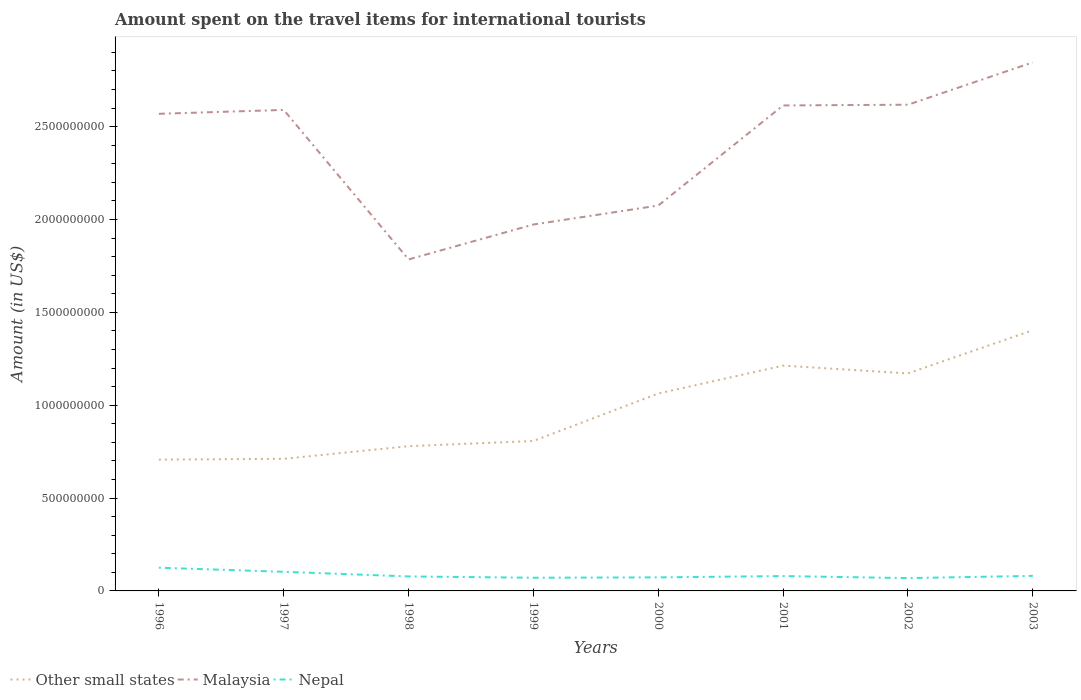Is the number of lines equal to the number of legend labels?
Give a very brief answer. Yes. Across all years, what is the maximum amount spent on the travel items for international tourists in Nepal?
Make the answer very short. 6.90e+07. What is the total amount spent on the travel items for international tourists in Other small states in the graph?
Make the answer very short. -5.02e+08. What is the difference between the highest and the second highest amount spent on the travel items for international tourists in Malaysia?
Keep it short and to the point. 1.06e+09. Is the amount spent on the travel items for international tourists in Nepal strictly greater than the amount spent on the travel items for international tourists in Malaysia over the years?
Your answer should be compact. Yes. How many years are there in the graph?
Your answer should be very brief. 8. What is the difference between two consecutive major ticks on the Y-axis?
Offer a very short reply. 5.00e+08. Does the graph contain any zero values?
Provide a succinct answer. No. How are the legend labels stacked?
Make the answer very short. Horizontal. What is the title of the graph?
Make the answer very short. Amount spent on the travel items for international tourists. What is the label or title of the Y-axis?
Provide a short and direct response. Amount (in US$). What is the Amount (in US$) of Other small states in 1996?
Your answer should be compact. 7.07e+08. What is the Amount (in US$) in Malaysia in 1996?
Offer a very short reply. 2.57e+09. What is the Amount (in US$) of Nepal in 1996?
Your answer should be very brief. 1.25e+08. What is the Amount (in US$) in Other small states in 1997?
Keep it short and to the point. 7.11e+08. What is the Amount (in US$) in Malaysia in 1997?
Your answer should be very brief. 2.59e+09. What is the Amount (in US$) in Nepal in 1997?
Offer a terse response. 1.03e+08. What is the Amount (in US$) of Other small states in 1998?
Provide a short and direct response. 7.79e+08. What is the Amount (in US$) in Malaysia in 1998?
Your answer should be very brief. 1.78e+09. What is the Amount (in US$) in Nepal in 1998?
Ensure brevity in your answer.  7.80e+07. What is the Amount (in US$) of Other small states in 1999?
Provide a short and direct response. 8.07e+08. What is the Amount (in US$) in Malaysia in 1999?
Your answer should be compact. 1.97e+09. What is the Amount (in US$) of Nepal in 1999?
Your answer should be very brief. 7.10e+07. What is the Amount (in US$) in Other small states in 2000?
Keep it short and to the point. 1.06e+09. What is the Amount (in US$) in Malaysia in 2000?
Provide a short and direct response. 2.08e+09. What is the Amount (in US$) in Nepal in 2000?
Ensure brevity in your answer.  7.30e+07. What is the Amount (in US$) in Other small states in 2001?
Offer a very short reply. 1.21e+09. What is the Amount (in US$) in Malaysia in 2001?
Your answer should be very brief. 2.61e+09. What is the Amount (in US$) in Nepal in 2001?
Your answer should be very brief. 8.00e+07. What is the Amount (in US$) in Other small states in 2002?
Give a very brief answer. 1.17e+09. What is the Amount (in US$) of Malaysia in 2002?
Ensure brevity in your answer.  2.62e+09. What is the Amount (in US$) of Nepal in 2002?
Your answer should be compact. 6.90e+07. What is the Amount (in US$) of Other small states in 2003?
Provide a short and direct response. 1.40e+09. What is the Amount (in US$) of Malaysia in 2003?
Keep it short and to the point. 2.85e+09. What is the Amount (in US$) of Nepal in 2003?
Make the answer very short. 8.10e+07. Across all years, what is the maximum Amount (in US$) of Other small states?
Your answer should be very brief. 1.40e+09. Across all years, what is the maximum Amount (in US$) of Malaysia?
Keep it short and to the point. 2.85e+09. Across all years, what is the maximum Amount (in US$) of Nepal?
Offer a terse response. 1.25e+08. Across all years, what is the minimum Amount (in US$) in Other small states?
Your answer should be compact. 7.07e+08. Across all years, what is the minimum Amount (in US$) in Malaysia?
Make the answer very short. 1.78e+09. Across all years, what is the minimum Amount (in US$) in Nepal?
Your answer should be compact. 6.90e+07. What is the total Amount (in US$) in Other small states in the graph?
Keep it short and to the point. 7.86e+09. What is the total Amount (in US$) in Malaysia in the graph?
Your response must be concise. 1.91e+1. What is the total Amount (in US$) of Nepal in the graph?
Make the answer very short. 6.80e+08. What is the difference between the Amount (in US$) in Other small states in 1996 and that in 1997?
Your answer should be compact. -4.32e+06. What is the difference between the Amount (in US$) in Malaysia in 1996 and that in 1997?
Offer a terse response. -2.10e+07. What is the difference between the Amount (in US$) of Nepal in 1996 and that in 1997?
Provide a succinct answer. 2.20e+07. What is the difference between the Amount (in US$) of Other small states in 1996 and that in 1998?
Keep it short and to the point. -7.23e+07. What is the difference between the Amount (in US$) of Malaysia in 1996 and that in 1998?
Provide a short and direct response. 7.84e+08. What is the difference between the Amount (in US$) in Nepal in 1996 and that in 1998?
Your answer should be compact. 4.70e+07. What is the difference between the Amount (in US$) of Other small states in 1996 and that in 1999?
Offer a very short reply. -1.00e+08. What is the difference between the Amount (in US$) in Malaysia in 1996 and that in 1999?
Offer a terse response. 5.96e+08. What is the difference between the Amount (in US$) of Nepal in 1996 and that in 1999?
Your answer should be very brief. 5.40e+07. What is the difference between the Amount (in US$) of Other small states in 1996 and that in 2000?
Ensure brevity in your answer.  -3.56e+08. What is the difference between the Amount (in US$) in Malaysia in 1996 and that in 2000?
Keep it short and to the point. 4.94e+08. What is the difference between the Amount (in US$) of Nepal in 1996 and that in 2000?
Your response must be concise. 5.20e+07. What is the difference between the Amount (in US$) in Other small states in 1996 and that in 2001?
Your answer should be compact. -5.06e+08. What is the difference between the Amount (in US$) of Malaysia in 1996 and that in 2001?
Your response must be concise. -4.50e+07. What is the difference between the Amount (in US$) in Nepal in 1996 and that in 2001?
Offer a terse response. 4.50e+07. What is the difference between the Amount (in US$) of Other small states in 1996 and that in 2002?
Your answer should be compact. -4.64e+08. What is the difference between the Amount (in US$) in Malaysia in 1996 and that in 2002?
Offer a very short reply. -4.90e+07. What is the difference between the Amount (in US$) of Nepal in 1996 and that in 2002?
Offer a terse response. 5.60e+07. What is the difference between the Amount (in US$) in Other small states in 1996 and that in 2003?
Provide a short and direct response. -6.97e+08. What is the difference between the Amount (in US$) of Malaysia in 1996 and that in 2003?
Your answer should be compact. -2.77e+08. What is the difference between the Amount (in US$) in Nepal in 1996 and that in 2003?
Your answer should be compact. 4.40e+07. What is the difference between the Amount (in US$) in Other small states in 1997 and that in 1998?
Give a very brief answer. -6.80e+07. What is the difference between the Amount (in US$) of Malaysia in 1997 and that in 1998?
Offer a very short reply. 8.05e+08. What is the difference between the Amount (in US$) in Nepal in 1997 and that in 1998?
Offer a terse response. 2.50e+07. What is the difference between the Amount (in US$) of Other small states in 1997 and that in 1999?
Offer a terse response. -9.60e+07. What is the difference between the Amount (in US$) of Malaysia in 1997 and that in 1999?
Ensure brevity in your answer.  6.17e+08. What is the difference between the Amount (in US$) of Nepal in 1997 and that in 1999?
Your response must be concise. 3.20e+07. What is the difference between the Amount (in US$) of Other small states in 1997 and that in 2000?
Your response must be concise. -3.52e+08. What is the difference between the Amount (in US$) in Malaysia in 1997 and that in 2000?
Your answer should be very brief. 5.15e+08. What is the difference between the Amount (in US$) in Nepal in 1997 and that in 2000?
Ensure brevity in your answer.  3.00e+07. What is the difference between the Amount (in US$) of Other small states in 1997 and that in 2001?
Your response must be concise. -5.02e+08. What is the difference between the Amount (in US$) in Malaysia in 1997 and that in 2001?
Your answer should be very brief. -2.40e+07. What is the difference between the Amount (in US$) of Nepal in 1997 and that in 2001?
Your answer should be very brief. 2.30e+07. What is the difference between the Amount (in US$) in Other small states in 1997 and that in 2002?
Make the answer very short. -4.60e+08. What is the difference between the Amount (in US$) in Malaysia in 1997 and that in 2002?
Your answer should be compact. -2.80e+07. What is the difference between the Amount (in US$) in Nepal in 1997 and that in 2002?
Give a very brief answer. 3.40e+07. What is the difference between the Amount (in US$) in Other small states in 1997 and that in 2003?
Your answer should be compact. -6.92e+08. What is the difference between the Amount (in US$) of Malaysia in 1997 and that in 2003?
Ensure brevity in your answer.  -2.56e+08. What is the difference between the Amount (in US$) in Nepal in 1997 and that in 2003?
Give a very brief answer. 2.20e+07. What is the difference between the Amount (in US$) of Other small states in 1998 and that in 1999?
Make the answer very short. -2.80e+07. What is the difference between the Amount (in US$) of Malaysia in 1998 and that in 1999?
Offer a very short reply. -1.88e+08. What is the difference between the Amount (in US$) in Other small states in 1998 and that in 2000?
Make the answer very short. -2.84e+08. What is the difference between the Amount (in US$) in Malaysia in 1998 and that in 2000?
Your response must be concise. -2.90e+08. What is the difference between the Amount (in US$) of Nepal in 1998 and that in 2000?
Offer a terse response. 5.00e+06. What is the difference between the Amount (in US$) in Other small states in 1998 and that in 2001?
Provide a succinct answer. -4.34e+08. What is the difference between the Amount (in US$) of Malaysia in 1998 and that in 2001?
Make the answer very short. -8.29e+08. What is the difference between the Amount (in US$) of Nepal in 1998 and that in 2001?
Make the answer very short. -2.00e+06. What is the difference between the Amount (in US$) in Other small states in 1998 and that in 2002?
Offer a terse response. -3.92e+08. What is the difference between the Amount (in US$) of Malaysia in 1998 and that in 2002?
Your response must be concise. -8.33e+08. What is the difference between the Amount (in US$) of Nepal in 1998 and that in 2002?
Your answer should be very brief. 9.00e+06. What is the difference between the Amount (in US$) in Other small states in 1998 and that in 2003?
Your answer should be very brief. -6.24e+08. What is the difference between the Amount (in US$) in Malaysia in 1998 and that in 2003?
Ensure brevity in your answer.  -1.06e+09. What is the difference between the Amount (in US$) of Nepal in 1998 and that in 2003?
Provide a succinct answer. -3.00e+06. What is the difference between the Amount (in US$) of Other small states in 1999 and that in 2000?
Your answer should be compact. -2.56e+08. What is the difference between the Amount (in US$) in Malaysia in 1999 and that in 2000?
Your response must be concise. -1.02e+08. What is the difference between the Amount (in US$) in Other small states in 1999 and that in 2001?
Offer a very short reply. -4.06e+08. What is the difference between the Amount (in US$) of Malaysia in 1999 and that in 2001?
Offer a very short reply. -6.41e+08. What is the difference between the Amount (in US$) of Nepal in 1999 and that in 2001?
Your answer should be compact. -9.00e+06. What is the difference between the Amount (in US$) of Other small states in 1999 and that in 2002?
Offer a very short reply. -3.64e+08. What is the difference between the Amount (in US$) of Malaysia in 1999 and that in 2002?
Your answer should be compact. -6.45e+08. What is the difference between the Amount (in US$) in Nepal in 1999 and that in 2002?
Make the answer very short. 2.00e+06. What is the difference between the Amount (in US$) of Other small states in 1999 and that in 2003?
Your answer should be very brief. -5.96e+08. What is the difference between the Amount (in US$) in Malaysia in 1999 and that in 2003?
Keep it short and to the point. -8.73e+08. What is the difference between the Amount (in US$) of Nepal in 1999 and that in 2003?
Ensure brevity in your answer.  -1.00e+07. What is the difference between the Amount (in US$) of Other small states in 2000 and that in 2001?
Ensure brevity in your answer.  -1.50e+08. What is the difference between the Amount (in US$) in Malaysia in 2000 and that in 2001?
Offer a terse response. -5.39e+08. What is the difference between the Amount (in US$) in Nepal in 2000 and that in 2001?
Provide a succinct answer. -7.00e+06. What is the difference between the Amount (in US$) in Other small states in 2000 and that in 2002?
Provide a short and direct response. -1.08e+08. What is the difference between the Amount (in US$) in Malaysia in 2000 and that in 2002?
Offer a very short reply. -5.43e+08. What is the difference between the Amount (in US$) of Nepal in 2000 and that in 2002?
Give a very brief answer. 4.00e+06. What is the difference between the Amount (in US$) of Other small states in 2000 and that in 2003?
Make the answer very short. -3.41e+08. What is the difference between the Amount (in US$) in Malaysia in 2000 and that in 2003?
Offer a terse response. -7.71e+08. What is the difference between the Amount (in US$) of Nepal in 2000 and that in 2003?
Offer a terse response. -8.00e+06. What is the difference between the Amount (in US$) of Other small states in 2001 and that in 2002?
Provide a succinct answer. 4.19e+07. What is the difference between the Amount (in US$) in Nepal in 2001 and that in 2002?
Offer a terse response. 1.10e+07. What is the difference between the Amount (in US$) of Other small states in 2001 and that in 2003?
Your answer should be compact. -1.91e+08. What is the difference between the Amount (in US$) in Malaysia in 2001 and that in 2003?
Provide a short and direct response. -2.32e+08. What is the difference between the Amount (in US$) in Other small states in 2002 and that in 2003?
Make the answer very short. -2.32e+08. What is the difference between the Amount (in US$) in Malaysia in 2002 and that in 2003?
Give a very brief answer. -2.28e+08. What is the difference between the Amount (in US$) in Nepal in 2002 and that in 2003?
Keep it short and to the point. -1.20e+07. What is the difference between the Amount (in US$) in Other small states in 1996 and the Amount (in US$) in Malaysia in 1997?
Offer a terse response. -1.88e+09. What is the difference between the Amount (in US$) of Other small states in 1996 and the Amount (in US$) of Nepal in 1997?
Offer a terse response. 6.04e+08. What is the difference between the Amount (in US$) in Malaysia in 1996 and the Amount (in US$) in Nepal in 1997?
Give a very brief answer. 2.47e+09. What is the difference between the Amount (in US$) in Other small states in 1996 and the Amount (in US$) in Malaysia in 1998?
Provide a succinct answer. -1.08e+09. What is the difference between the Amount (in US$) in Other small states in 1996 and the Amount (in US$) in Nepal in 1998?
Make the answer very short. 6.29e+08. What is the difference between the Amount (in US$) of Malaysia in 1996 and the Amount (in US$) of Nepal in 1998?
Your response must be concise. 2.49e+09. What is the difference between the Amount (in US$) in Other small states in 1996 and the Amount (in US$) in Malaysia in 1999?
Make the answer very short. -1.27e+09. What is the difference between the Amount (in US$) of Other small states in 1996 and the Amount (in US$) of Nepal in 1999?
Give a very brief answer. 6.36e+08. What is the difference between the Amount (in US$) in Malaysia in 1996 and the Amount (in US$) in Nepal in 1999?
Offer a very short reply. 2.50e+09. What is the difference between the Amount (in US$) of Other small states in 1996 and the Amount (in US$) of Malaysia in 2000?
Your answer should be compact. -1.37e+09. What is the difference between the Amount (in US$) in Other small states in 1996 and the Amount (in US$) in Nepal in 2000?
Make the answer very short. 6.34e+08. What is the difference between the Amount (in US$) in Malaysia in 1996 and the Amount (in US$) in Nepal in 2000?
Provide a short and direct response. 2.50e+09. What is the difference between the Amount (in US$) of Other small states in 1996 and the Amount (in US$) of Malaysia in 2001?
Your response must be concise. -1.91e+09. What is the difference between the Amount (in US$) of Other small states in 1996 and the Amount (in US$) of Nepal in 2001?
Keep it short and to the point. 6.27e+08. What is the difference between the Amount (in US$) in Malaysia in 1996 and the Amount (in US$) in Nepal in 2001?
Your answer should be very brief. 2.49e+09. What is the difference between the Amount (in US$) of Other small states in 1996 and the Amount (in US$) of Malaysia in 2002?
Keep it short and to the point. -1.91e+09. What is the difference between the Amount (in US$) of Other small states in 1996 and the Amount (in US$) of Nepal in 2002?
Give a very brief answer. 6.38e+08. What is the difference between the Amount (in US$) in Malaysia in 1996 and the Amount (in US$) in Nepal in 2002?
Give a very brief answer. 2.50e+09. What is the difference between the Amount (in US$) of Other small states in 1996 and the Amount (in US$) of Malaysia in 2003?
Your answer should be compact. -2.14e+09. What is the difference between the Amount (in US$) in Other small states in 1996 and the Amount (in US$) in Nepal in 2003?
Provide a short and direct response. 6.26e+08. What is the difference between the Amount (in US$) in Malaysia in 1996 and the Amount (in US$) in Nepal in 2003?
Offer a terse response. 2.49e+09. What is the difference between the Amount (in US$) in Other small states in 1997 and the Amount (in US$) in Malaysia in 1998?
Provide a succinct answer. -1.07e+09. What is the difference between the Amount (in US$) in Other small states in 1997 and the Amount (in US$) in Nepal in 1998?
Your response must be concise. 6.33e+08. What is the difference between the Amount (in US$) of Malaysia in 1997 and the Amount (in US$) of Nepal in 1998?
Your answer should be very brief. 2.51e+09. What is the difference between the Amount (in US$) of Other small states in 1997 and the Amount (in US$) of Malaysia in 1999?
Your answer should be compact. -1.26e+09. What is the difference between the Amount (in US$) in Other small states in 1997 and the Amount (in US$) in Nepal in 1999?
Give a very brief answer. 6.40e+08. What is the difference between the Amount (in US$) in Malaysia in 1997 and the Amount (in US$) in Nepal in 1999?
Your answer should be compact. 2.52e+09. What is the difference between the Amount (in US$) in Other small states in 1997 and the Amount (in US$) in Malaysia in 2000?
Provide a succinct answer. -1.36e+09. What is the difference between the Amount (in US$) in Other small states in 1997 and the Amount (in US$) in Nepal in 2000?
Your answer should be very brief. 6.38e+08. What is the difference between the Amount (in US$) of Malaysia in 1997 and the Amount (in US$) of Nepal in 2000?
Give a very brief answer. 2.52e+09. What is the difference between the Amount (in US$) of Other small states in 1997 and the Amount (in US$) of Malaysia in 2001?
Keep it short and to the point. -1.90e+09. What is the difference between the Amount (in US$) in Other small states in 1997 and the Amount (in US$) in Nepal in 2001?
Offer a terse response. 6.31e+08. What is the difference between the Amount (in US$) in Malaysia in 1997 and the Amount (in US$) in Nepal in 2001?
Your answer should be compact. 2.51e+09. What is the difference between the Amount (in US$) in Other small states in 1997 and the Amount (in US$) in Malaysia in 2002?
Ensure brevity in your answer.  -1.91e+09. What is the difference between the Amount (in US$) of Other small states in 1997 and the Amount (in US$) of Nepal in 2002?
Make the answer very short. 6.42e+08. What is the difference between the Amount (in US$) in Malaysia in 1997 and the Amount (in US$) in Nepal in 2002?
Make the answer very short. 2.52e+09. What is the difference between the Amount (in US$) in Other small states in 1997 and the Amount (in US$) in Malaysia in 2003?
Ensure brevity in your answer.  -2.13e+09. What is the difference between the Amount (in US$) in Other small states in 1997 and the Amount (in US$) in Nepal in 2003?
Keep it short and to the point. 6.30e+08. What is the difference between the Amount (in US$) in Malaysia in 1997 and the Amount (in US$) in Nepal in 2003?
Your answer should be very brief. 2.51e+09. What is the difference between the Amount (in US$) in Other small states in 1998 and the Amount (in US$) in Malaysia in 1999?
Make the answer very short. -1.19e+09. What is the difference between the Amount (in US$) of Other small states in 1998 and the Amount (in US$) of Nepal in 1999?
Your answer should be very brief. 7.08e+08. What is the difference between the Amount (in US$) of Malaysia in 1998 and the Amount (in US$) of Nepal in 1999?
Your response must be concise. 1.71e+09. What is the difference between the Amount (in US$) in Other small states in 1998 and the Amount (in US$) in Malaysia in 2000?
Your answer should be very brief. -1.30e+09. What is the difference between the Amount (in US$) of Other small states in 1998 and the Amount (in US$) of Nepal in 2000?
Ensure brevity in your answer.  7.06e+08. What is the difference between the Amount (in US$) in Malaysia in 1998 and the Amount (in US$) in Nepal in 2000?
Provide a short and direct response. 1.71e+09. What is the difference between the Amount (in US$) in Other small states in 1998 and the Amount (in US$) in Malaysia in 2001?
Offer a very short reply. -1.83e+09. What is the difference between the Amount (in US$) in Other small states in 1998 and the Amount (in US$) in Nepal in 2001?
Keep it short and to the point. 6.99e+08. What is the difference between the Amount (in US$) of Malaysia in 1998 and the Amount (in US$) of Nepal in 2001?
Your response must be concise. 1.70e+09. What is the difference between the Amount (in US$) of Other small states in 1998 and the Amount (in US$) of Malaysia in 2002?
Your answer should be very brief. -1.84e+09. What is the difference between the Amount (in US$) in Other small states in 1998 and the Amount (in US$) in Nepal in 2002?
Provide a succinct answer. 7.10e+08. What is the difference between the Amount (in US$) in Malaysia in 1998 and the Amount (in US$) in Nepal in 2002?
Offer a terse response. 1.72e+09. What is the difference between the Amount (in US$) of Other small states in 1998 and the Amount (in US$) of Malaysia in 2003?
Make the answer very short. -2.07e+09. What is the difference between the Amount (in US$) of Other small states in 1998 and the Amount (in US$) of Nepal in 2003?
Your answer should be very brief. 6.98e+08. What is the difference between the Amount (in US$) in Malaysia in 1998 and the Amount (in US$) in Nepal in 2003?
Your answer should be very brief. 1.70e+09. What is the difference between the Amount (in US$) of Other small states in 1999 and the Amount (in US$) of Malaysia in 2000?
Ensure brevity in your answer.  -1.27e+09. What is the difference between the Amount (in US$) of Other small states in 1999 and the Amount (in US$) of Nepal in 2000?
Keep it short and to the point. 7.34e+08. What is the difference between the Amount (in US$) in Malaysia in 1999 and the Amount (in US$) in Nepal in 2000?
Ensure brevity in your answer.  1.90e+09. What is the difference between the Amount (in US$) of Other small states in 1999 and the Amount (in US$) of Malaysia in 2001?
Keep it short and to the point. -1.81e+09. What is the difference between the Amount (in US$) of Other small states in 1999 and the Amount (in US$) of Nepal in 2001?
Provide a short and direct response. 7.27e+08. What is the difference between the Amount (in US$) of Malaysia in 1999 and the Amount (in US$) of Nepal in 2001?
Your answer should be compact. 1.89e+09. What is the difference between the Amount (in US$) in Other small states in 1999 and the Amount (in US$) in Malaysia in 2002?
Provide a succinct answer. -1.81e+09. What is the difference between the Amount (in US$) in Other small states in 1999 and the Amount (in US$) in Nepal in 2002?
Ensure brevity in your answer.  7.38e+08. What is the difference between the Amount (in US$) of Malaysia in 1999 and the Amount (in US$) of Nepal in 2002?
Your answer should be very brief. 1.90e+09. What is the difference between the Amount (in US$) of Other small states in 1999 and the Amount (in US$) of Malaysia in 2003?
Your answer should be compact. -2.04e+09. What is the difference between the Amount (in US$) of Other small states in 1999 and the Amount (in US$) of Nepal in 2003?
Your answer should be compact. 7.26e+08. What is the difference between the Amount (in US$) in Malaysia in 1999 and the Amount (in US$) in Nepal in 2003?
Offer a terse response. 1.89e+09. What is the difference between the Amount (in US$) of Other small states in 2000 and the Amount (in US$) of Malaysia in 2001?
Provide a succinct answer. -1.55e+09. What is the difference between the Amount (in US$) of Other small states in 2000 and the Amount (in US$) of Nepal in 2001?
Give a very brief answer. 9.83e+08. What is the difference between the Amount (in US$) in Malaysia in 2000 and the Amount (in US$) in Nepal in 2001?
Provide a succinct answer. 2.00e+09. What is the difference between the Amount (in US$) in Other small states in 2000 and the Amount (in US$) in Malaysia in 2002?
Keep it short and to the point. -1.56e+09. What is the difference between the Amount (in US$) of Other small states in 2000 and the Amount (in US$) of Nepal in 2002?
Offer a terse response. 9.94e+08. What is the difference between the Amount (in US$) of Malaysia in 2000 and the Amount (in US$) of Nepal in 2002?
Provide a succinct answer. 2.01e+09. What is the difference between the Amount (in US$) of Other small states in 2000 and the Amount (in US$) of Malaysia in 2003?
Offer a terse response. -1.78e+09. What is the difference between the Amount (in US$) of Other small states in 2000 and the Amount (in US$) of Nepal in 2003?
Your response must be concise. 9.82e+08. What is the difference between the Amount (in US$) in Malaysia in 2000 and the Amount (in US$) in Nepal in 2003?
Provide a short and direct response. 1.99e+09. What is the difference between the Amount (in US$) of Other small states in 2001 and the Amount (in US$) of Malaysia in 2002?
Your response must be concise. -1.40e+09. What is the difference between the Amount (in US$) in Other small states in 2001 and the Amount (in US$) in Nepal in 2002?
Your answer should be very brief. 1.14e+09. What is the difference between the Amount (in US$) of Malaysia in 2001 and the Amount (in US$) of Nepal in 2002?
Offer a very short reply. 2.54e+09. What is the difference between the Amount (in US$) in Other small states in 2001 and the Amount (in US$) in Malaysia in 2003?
Provide a short and direct response. -1.63e+09. What is the difference between the Amount (in US$) in Other small states in 2001 and the Amount (in US$) in Nepal in 2003?
Your response must be concise. 1.13e+09. What is the difference between the Amount (in US$) of Malaysia in 2001 and the Amount (in US$) of Nepal in 2003?
Give a very brief answer. 2.53e+09. What is the difference between the Amount (in US$) in Other small states in 2002 and the Amount (in US$) in Malaysia in 2003?
Provide a succinct answer. -1.67e+09. What is the difference between the Amount (in US$) in Other small states in 2002 and the Amount (in US$) in Nepal in 2003?
Offer a very short reply. 1.09e+09. What is the difference between the Amount (in US$) in Malaysia in 2002 and the Amount (in US$) in Nepal in 2003?
Offer a terse response. 2.54e+09. What is the average Amount (in US$) of Other small states per year?
Your answer should be compact. 9.82e+08. What is the average Amount (in US$) in Malaysia per year?
Provide a succinct answer. 2.38e+09. What is the average Amount (in US$) of Nepal per year?
Ensure brevity in your answer.  8.50e+07. In the year 1996, what is the difference between the Amount (in US$) of Other small states and Amount (in US$) of Malaysia?
Your answer should be compact. -1.86e+09. In the year 1996, what is the difference between the Amount (in US$) of Other small states and Amount (in US$) of Nepal?
Make the answer very short. 5.82e+08. In the year 1996, what is the difference between the Amount (in US$) in Malaysia and Amount (in US$) in Nepal?
Your response must be concise. 2.44e+09. In the year 1997, what is the difference between the Amount (in US$) in Other small states and Amount (in US$) in Malaysia?
Give a very brief answer. -1.88e+09. In the year 1997, what is the difference between the Amount (in US$) in Other small states and Amount (in US$) in Nepal?
Provide a succinct answer. 6.08e+08. In the year 1997, what is the difference between the Amount (in US$) of Malaysia and Amount (in US$) of Nepal?
Ensure brevity in your answer.  2.49e+09. In the year 1998, what is the difference between the Amount (in US$) in Other small states and Amount (in US$) in Malaysia?
Offer a very short reply. -1.01e+09. In the year 1998, what is the difference between the Amount (in US$) of Other small states and Amount (in US$) of Nepal?
Make the answer very short. 7.01e+08. In the year 1998, what is the difference between the Amount (in US$) in Malaysia and Amount (in US$) in Nepal?
Ensure brevity in your answer.  1.71e+09. In the year 1999, what is the difference between the Amount (in US$) in Other small states and Amount (in US$) in Malaysia?
Give a very brief answer. -1.17e+09. In the year 1999, what is the difference between the Amount (in US$) in Other small states and Amount (in US$) in Nepal?
Give a very brief answer. 7.36e+08. In the year 1999, what is the difference between the Amount (in US$) in Malaysia and Amount (in US$) in Nepal?
Offer a very short reply. 1.90e+09. In the year 2000, what is the difference between the Amount (in US$) in Other small states and Amount (in US$) in Malaysia?
Ensure brevity in your answer.  -1.01e+09. In the year 2000, what is the difference between the Amount (in US$) of Other small states and Amount (in US$) of Nepal?
Offer a very short reply. 9.90e+08. In the year 2000, what is the difference between the Amount (in US$) in Malaysia and Amount (in US$) in Nepal?
Your response must be concise. 2.00e+09. In the year 2001, what is the difference between the Amount (in US$) in Other small states and Amount (in US$) in Malaysia?
Make the answer very short. -1.40e+09. In the year 2001, what is the difference between the Amount (in US$) of Other small states and Amount (in US$) of Nepal?
Your answer should be compact. 1.13e+09. In the year 2001, what is the difference between the Amount (in US$) in Malaysia and Amount (in US$) in Nepal?
Offer a terse response. 2.53e+09. In the year 2002, what is the difference between the Amount (in US$) in Other small states and Amount (in US$) in Malaysia?
Your response must be concise. -1.45e+09. In the year 2002, what is the difference between the Amount (in US$) of Other small states and Amount (in US$) of Nepal?
Give a very brief answer. 1.10e+09. In the year 2002, what is the difference between the Amount (in US$) in Malaysia and Amount (in US$) in Nepal?
Your answer should be compact. 2.55e+09. In the year 2003, what is the difference between the Amount (in US$) in Other small states and Amount (in US$) in Malaysia?
Your answer should be very brief. -1.44e+09. In the year 2003, what is the difference between the Amount (in US$) of Other small states and Amount (in US$) of Nepal?
Your answer should be very brief. 1.32e+09. In the year 2003, what is the difference between the Amount (in US$) of Malaysia and Amount (in US$) of Nepal?
Make the answer very short. 2.76e+09. What is the ratio of the Amount (in US$) in Malaysia in 1996 to that in 1997?
Provide a succinct answer. 0.99. What is the ratio of the Amount (in US$) of Nepal in 1996 to that in 1997?
Provide a succinct answer. 1.21. What is the ratio of the Amount (in US$) in Other small states in 1996 to that in 1998?
Provide a short and direct response. 0.91. What is the ratio of the Amount (in US$) of Malaysia in 1996 to that in 1998?
Provide a short and direct response. 1.44. What is the ratio of the Amount (in US$) in Nepal in 1996 to that in 1998?
Make the answer very short. 1.6. What is the ratio of the Amount (in US$) in Other small states in 1996 to that in 1999?
Your answer should be compact. 0.88. What is the ratio of the Amount (in US$) of Malaysia in 1996 to that in 1999?
Give a very brief answer. 1.3. What is the ratio of the Amount (in US$) in Nepal in 1996 to that in 1999?
Give a very brief answer. 1.76. What is the ratio of the Amount (in US$) in Other small states in 1996 to that in 2000?
Offer a terse response. 0.67. What is the ratio of the Amount (in US$) of Malaysia in 1996 to that in 2000?
Give a very brief answer. 1.24. What is the ratio of the Amount (in US$) in Nepal in 1996 to that in 2000?
Provide a succinct answer. 1.71. What is the ratio of the Amount (in US$) in Other small states in 1996 to that in 2001?
Your answer should be very brief. 0.58. What is the ratio of the Amount (in US$) of Malaysia in 1996 to that in 2001?
Provide a short and direct response. 0.98. What is the ratio of the Amount (in US$) in Nepal in 1996 to that in 2001?
Offer a terse response. 1.56. What is the ratio of the Amount (in US$) of Other small states in 1996 to that in 2002?
Provide a short and direct response. 0.6. What is the ratio of the Amount (in US$) in Malaysia in 1996 to that in 2002?
Offer a terse response. 0.98. What is the ratio of the Amount (in US$) of Nepal in 1996 to that in 2002?
Offer a terse response. 1.81. What is the ratio of the Amount (in US$) of Other small states in 1996 to that in 2003?
Give a very brief answer. 0.5. What is the ratio of the Amount (in US$) in Malaysia in 1996 to that in 2003?
Ensure brevity in your answer.  0.9. What is the ratio of the Amount (in US$) in Nepal in 1996 to that in 2003?
Your response must be concise. 1.54. What is the ratio of the Amount (in US$) of Other small states in 1997 to that in 1998?
Your answer should be compact. 0.91. What is the ratio of the Amount (in US$) of Malaysia in 1997 to that in 1998?
Make the answer very short. 1.45. What is the ratio of the Amount (in US$) in Nepal in 1997 to that in 1998?
Your answer should be compact. 1.32. What is the ratio of the Amount (in US$) in Other small states in 1997 to that in 1999?
Your answer should be compact. 0.88. What is the ratio of the Amount (in US$) of Malaysia in 1997 to that in 1999?
Keep it short and to the point. 1.31. What is the ratio of the Amount (in US$) in Nepal in 1997 to that in 1999?
Your response must be concise. 1.45. What is the ratio of the Amount (in US$) of Other small states in 1997 to that in 2000?
Offer a very short reply. 0.67. What is the ratio of the Amount (in US$) of Malaysia in 1997 to that in 2000?
Your answer should be very brief. 1.25. What is the ratio of the Amount (in US$) in Nepal in 1997 to that in 2000?
Provide a succinct answer. 1.41. What is the ratio of the Amount (in US$) of Other small states in 1997 to that in 2001?
Offer a terse response. 0.59. What is the ratio of the Amount (in US$) in Malaysia in 1997 to that in 2001?
Provide a short and direct response. 0.99. What is the ratio of the Amount (in US$) in Nepal in 1997 to that in 2001?
Provide a short and direct response. 1.29. What is the ratio of the Amount (in US$) in Other small states in 1997 to that in 2002?
Your response must be concise. 0.61. What is the ratio of the Amount (in US$) in Malaysia in 1997 to that in 2002?
Your response must be concise. 0.99. What is the ratio of the Amount (in US$) in Nepal in 1997 to that in 2002?
Give a very brief answer. 1.49. What is the ratio of the Amount (in US$) of Other small states in 1997 to that in 2003?
Keep it short and to the point. 0.51. What is the ratio of the Amount (in US$) in Malaysia in 1997 to that in 2003?
Ensure brevity in your answer.  0.91. What is the ratio of the Amount (in US$) of Nepal in 1997 to that in 2003?
Provide a short and direct response. 1.27. What is the ratio of the Amount (in US$) of Other small states in 1998 to that in 1999?
Ensure brevity in your answer.  0.97. What is the ratio of the Amount (in US$) of Malaysia in 1998 to that in 1999?
Keep it short and to the point. 0.9. What is the ratio of the Amount (in US$) of Nepal in 1998 to that in 1999?
Offer a terse response. 1.1. What is the ratio of the Amount (in US$) in Other small states in 1998 to that in 2000?
Make the answer very short. 0.73. What is the ratio of the Amount (in US$) of Malaysia in 1998 to that in 2000?
Your response must be concise. 0.86. What is the ratio of the Amount (in US$) in Nepal in 1998 to that in 2000?
Provide a short and direct response. 1.07. What is the ratio of the Amount (in US$) in Other small states in 1998 to that in 2001?
Offer a terse response. 0.64. What is the ratio of the Amount (in US$) of Malaysia in 1998 to that in 2001?
Provide a short and direct response. 0.68. What is the ratio of the Amount (in US$) in Nepal in 1998 to that in 2001?
Provide a succinct answer. 0.97. What is the ratio of the Amount (in US$) in Other small states in 1998 to that in 2002?
Keep it short and to the point. 0.67. What is the ratio of the Amount (in US$) in Malaysia in 1998 to that in 2002?
Your answer should be compact. 0.68. What is the ratio of the Amount (in US$) in Nepal in 1998 to that in 2002?
Ensure brevity in your answer.  1.13. What is the ratio of the Amount (in US$) of Other small states in 1998 to that in 2003?
Provide a succinct answer. 0.56. What is the ratio of the Amount (in US$) of Malaysia in 1998 to that in 2003?
Your response must be concise. 0.63. What is the ratio of the Amount (in US$) in Other small states in 1999 to that in 2000?
Ensure brevity in your answer.  0.76. What is the ratio of the Amount (in US$) of Malaysia in 1999 to that in 2000?
Offer a terse response. 0.95. What is the ratio of the Amount (in US$) in Nepal in 1999 to that in 2000?
Keep it short and to the point. 0.97. What is the ratio of the Amount (in US$) in Other small states in 1999 to that in 2001?
Ensure brevity in your answer.  0.67. What is the ratio of the Amount (in US$) in Malaysia in 1999 to that in 2001?
Provide a short and direct response. 0.75. What is the ratio of the Amount (in US$) of Nepal in 1999 to that in 2001?
Your answer should be compact. 0.89. What is the ratio of the Amount (in US$) of Other small states in 1999 to that in 2002?
Provide a succinct answer. 0.69. What is the ratio of the Amount (in US$) of Malaysia in 1999 to that in 2002?
Your response must be concise. 0.75. What is the ratio of the Amount (in US$) in Other small states in 1999 to that in 2003?
Give a very brief answer. 0.58. What is the ratio of the Amount (in US$) in Malaysia in 1999 to that in 2003?
Your response must be concise. 0.69. What is the ratio of the Amount (in US$) in Nepal in 1999 to that in 2003?
Make the answer very short. 0.88. What is the ratio of the Amount (in US$) of Other small states in 2000 to that in 2001?
Your answer should be very brief. 0.88. What is the ratio of the Amount (in US$) in Malaysia in 2000 to that in 2001?
Provide a succinct answer. 0.79. What is the ratio of the Amount (in US$) in Nepal in 2000 to that in 2001?
Ensure brevity in your answer.  0.91. What is the ratio of the Amount (in US$) of Other small states in 2000 to that in 2002?
Provide a short and direct response. 0.91. What is the ratio of the Amount (in US$) in Malaysia in 2000 to that in 2002?
Your answer should be very brief. 0.79. What is the ratio of the Amount (in US$) of Nepal in 2000 to that in 2002?
Your response must be concise. 1.06. What is the ratio of the Amount (in US$) in Other small states in 2000 to that in 2003?
Your answer should be very brief. 0.76. What is the ratio of the Amount (in US$) of Malaysia in 2000 to that in 2003?
Ensure brevity in your answer.  0.73. What is the ratio of the Amount (in US$) of Nepal in 2000 to that in 2003?
Keep it short and to the point. 0.9. What is the ratio of the Amount (in US$) in Other small states in 2001 to that in 2002?
Ensure brevity in your answer.  1.04. What is the ratio of the Amount (in US$) of Malaysia in 2001 to that in 2002?
Keep it short and to the point. 1. What is the ratio of the Amount (in US$) in Nepal in 2001 to that in 2002?
Ensure brevity in your answer.  1.16. What is the ratio of the Amount (in US$) of Other small states in 2001 to that in 2003?
Offer a terse response. 0.86. What is the ratio of the Amount (in US$) of Malaysia in 2001 to that in 2003?
Provide a short and direct response. 0.92. What is the ratio of the Amount (in US$) in Other small states in 2002 to that in 2003?
Make the answer very short. 0.83. What is the ratio of the Amount (in US$) of Malaysia in 2002 to that in 2003?
Offer a very short reply. 0.92. What is the ratio of the Amount (in US$) in Nepal in 2002 to that in 2003?
Ensure brevity in your answer.  0.85. What is the difference between the highest and the second highest Amount (in US$) of Other small states?
Ensure brevity in your answer.  1.91e+08. What is the difference between the highest and the second highest Amount (in US$) in Malaysia?
Your answer should be compact. 2.28e+08. What is the difference between the highest and the second highest Amount (in US$) of Nepal?
Your answer should be compact. 2.20e+07. What is the difference between the highest and the lowest Amount (in US$) in Other small states?
Keep it short and to the point. 6.97e+08. What is the difference between the highest and the lowest Amount (in US$) in Malaysia?
Your answer should be compact. 1.06e+09. What is the difference between the highest and the lowest Amount (in US$) of Nepal?
Your answer should be compact. 5.60e+07. 